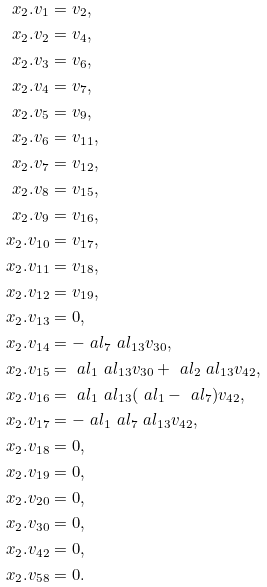<formula> <loc_0><loc_0><loc_500><loc_500>x _ { 2 } . v _ { 1 } & = v _ { 2 } , \\ x _ { 2 } . v _ { 2 } & = v _ { 4 } , \\ x _ { 2 } . v _ { 3 } & = v _ { 6 } , \\ x _ { 2 } . v _ { 4 } & = v _ { 7 } , \\ x _ { 2 } . v _ { 5 } & = v _ { 9 } , \\ x _ { 2 } . v _ { 6 } & = v _ { 1 1 } , \\ x _ { 2 } . v _ { 7 } & = v _ { 1 2 } , \\ x _ { 2 } . v _ { 8 } & = v _ { 1 5 } , \\ x _ { 2 } . v _ { 9 } & = v _ { 1 6 } , \\ x _ { 2 } . v _ { 1 0 } & = v _ { 1 7 } , \\ x _ { 2 } . v _ { 1 1 } & = v _ { 1 8 } , \\ x _ { 2 } . v _ { 1 2 } & = v _ { 1 9 } , \\ x _ { 2 } . v _ { 1 3 } & = 0 , \\ x _ { 2 } . v _ { 1 4 } & = - \ a l _ { 7 } \ a l _ { 1 3 } v _ { 3 0 } , \\ x _ { 2 } . v _ { 1 5 } & = \ a l _ { 1 } \ a l _ { 1 3 } v _ { 3 0 } + \ a l _ { 2 } \ a l _ { 1 3 } v _ { 4 2 } , \\ x _ { 2 } . v _ { 1 6 } & = \ a l _ { 1 } \ a l _ { 1 3 } ( \ a l _ { 1 } - \ a l _ { 7 } ) v _ { 4 2 } , \\ x _ { 2 } . v _ { 1 7 } & = - \ a l _ { 1 } \ a l _ { 7 } \ a l _ { 1 3 } v _ { 4 2 } , \\ x _ { 2 } . v _ { 1 8 } & = 0 , \\ x _ { 2 } . v _ { 1 9 } & = 0 , \\ x _ { 2 } . v _ { 2 0 } & = 0 , \\ x _ { 2 } . v _ { 3 0 } & = 0 , \\ x _ { 2 } . v _ { 4 2 } & = 0 , \\ x _ { 2 } . v _ { 5 8 } & = 0 .</formula> 